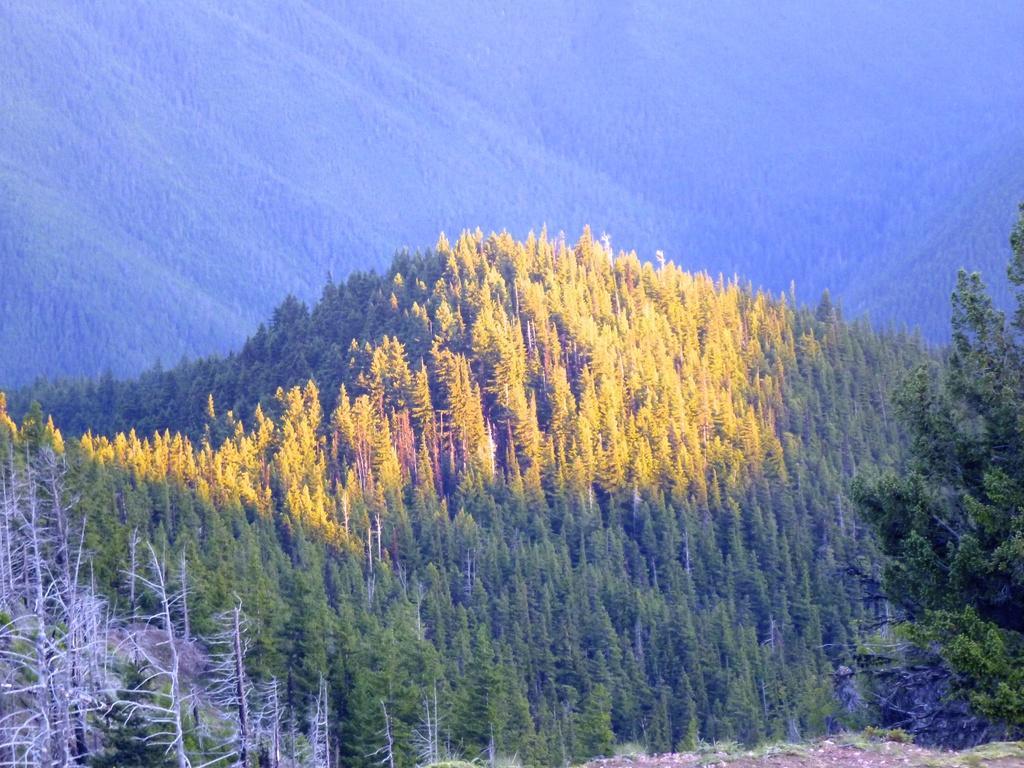In one or two sentences, can you explain what this image depicts? In this picture we can see trees and there is a blur background. 